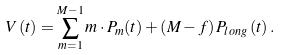Convert formula to latex. <formula><loc_0><loc_0><loc_500><loc_500>V \left ( t \right ) = \sum _ { m = 1 } ^ { M - 1 } m \cdot P _ { m } ( t ) + \left ( M - f \right ) P _ { l o n g } \left ( t \right ) .</formula> 